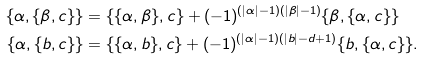<formula> <loc_0><loc_0><loc_500><loc_500>\{ \alpha , \{ \beta , c \} \} & = \{ \{ \alpha , \beta \} , c \} + ( - 1 ) ^ { ( | \alpha | - 1 ) ( | \beta | - 1 ) } \{ \beta , \{ \alpha , c \} \} \\ \{ \alpha , \{ b , c \} \} & = \{ \{ \alpha , b \} , c \} + ( - 1 ) ^ { ( | \alpha | - 1 ) ( | b | - d + 1 ) } \{ b , \{ \alpha , c \} \} .</formula> 